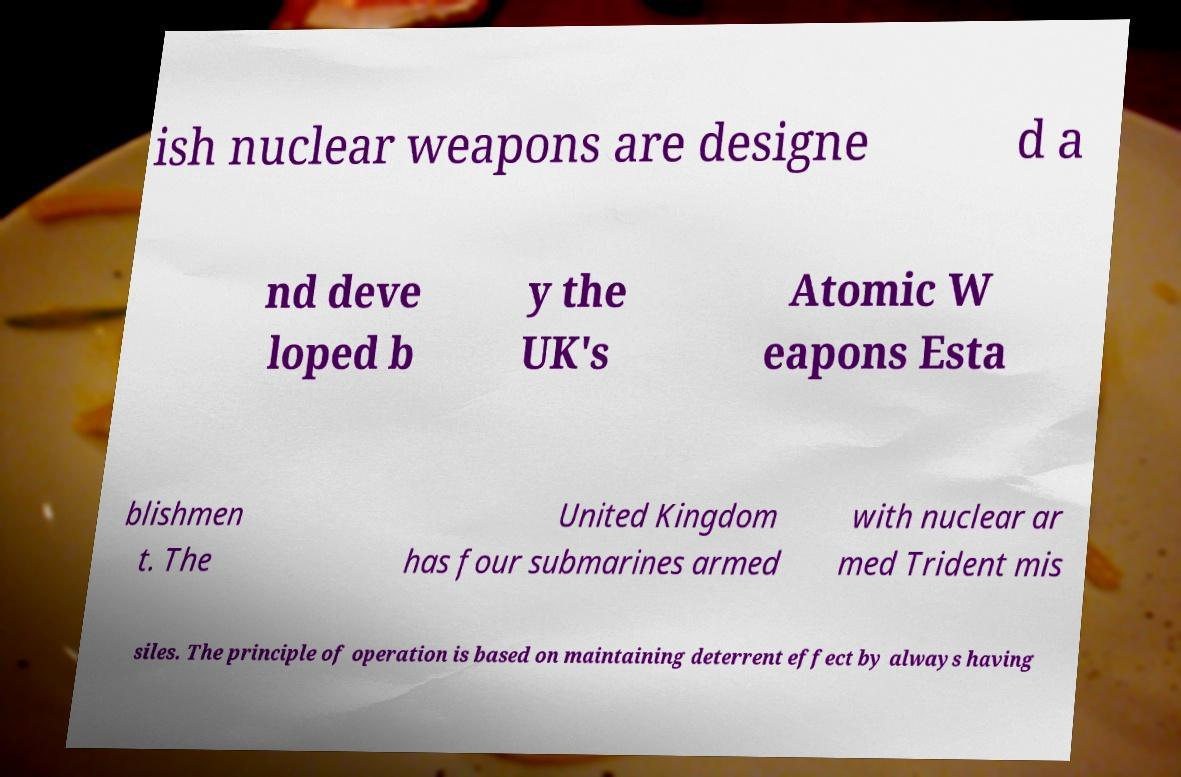For documentation purposes, I need the text within this image transcribed. Could you provide that? ish nuclear weapons are designe d a nd deve loped b y the UK's Atomic W eapons Esta blishmen t. The United Kingdom has four submarines armed with nuclear ar med Trident mis siles. The principle of operation is based on maintaining deterrent effect by always having 